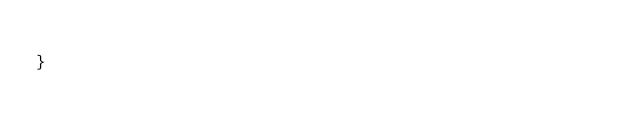Convert code to text. <code><loc_0><loc_0><loc_500><loc_500><_TypeScript_>
}
</code> 